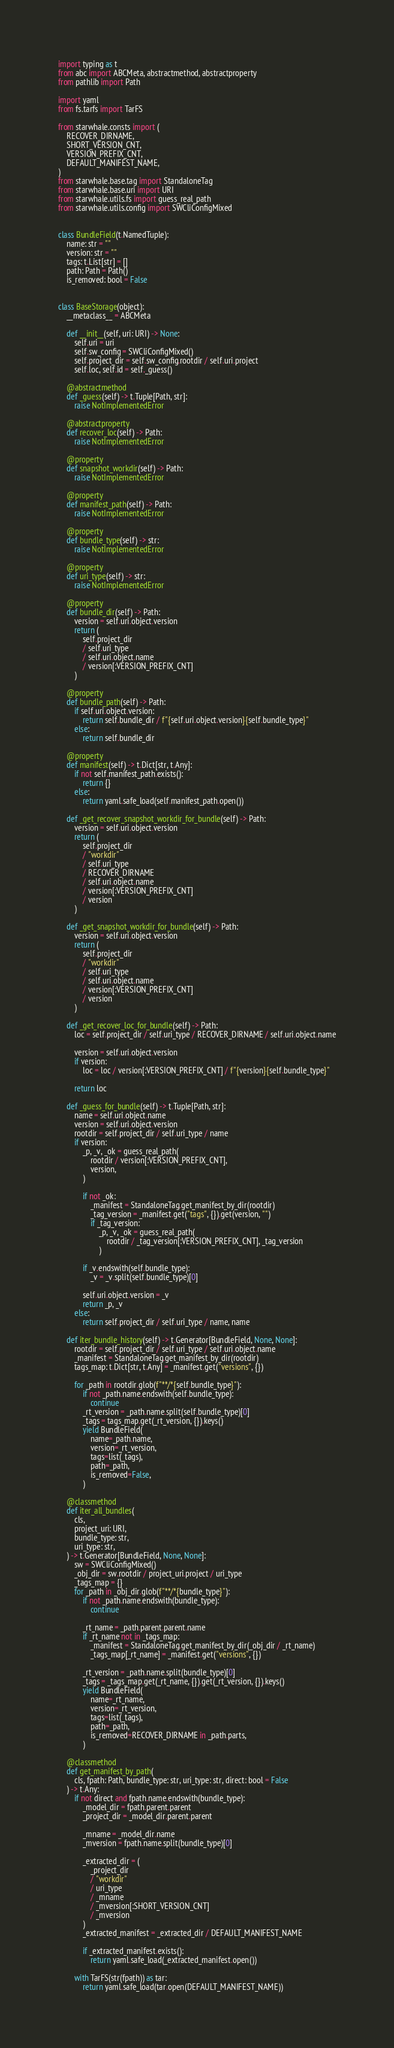<code> <loc_0><loc_0><loc_500><loc_500><_Python_>import typing as t
from abc import ABCMeta, abstractmethod, abstractproperty
from pathlib import Path

import yaml
from fs.tarfs import TarFS

from starwhale.consts import (
    RECOVER_DIRNAME,
    SHORT_VERSION_CNT,
    VERSION_PREFIX_CNT,
    DEFAULT_MANIFEST_NAME,
)
from starwhale.base.tag import StandaloneTag
from starwhale.base.uri import URI
from starwhale.utils.fs import guess_real_path
from starwhale.utils.config import SWCliConfigMixed


class BundleField(t.NamedTuple):
    name: str = ""
    version: str = ""
    tags: t.List[str] = []
    path: Path = Path()
    is_removed: bool = False


class BaseStorage(object):
    __metaclass__ = ABCMeta

    def __init__(self, uri: URI) -> None:
        self.uri = uri
        self.sw_config = SWCliConfigMixed()
        self.project_dir = self.sw_config.rootdir / self.uri.project
        self.loc, self.id = self._guess()

    @abstractmethod
    def _guess(self) -> t.Tuple[Path, str]:
        raise NotImplementedError

    @abstractproperty
    def recover_loc(self) -> Path:
        raise NotImplementedError

    @property
    def snapshot_workdir(self) -> Path:
        raise NotImplementedError

    @property
    def manifest_path(self) -> Path:
        raise NotImplementedError

    @property
    def bundle_type(self) -> str:
        raise NotImplementedError

    @property
    def uri_type(self) -> str:
        raise NotImplementedError

    @property
    def bundle_dir(self) -> Path:
        version = self.uri.object.version
        return (
            self.project_dir
            / self.uri_type
            / self.uri.object.name
            / version[:VERSION_PREFIX_CNT]
        )

    @property
    def bundle_path(self) -> Path:
        if self.uri.object.version:
            return self.bundle_dir / f"{self.uri.object.version}{self.bundle_type}"
        else:
            return self.bundle_dir

    @property
    def manifest(self) -> t.Dict[str, t.Any]:
        if not self.manifest_path.exists():
            return {}
        else:
            return yaml.safe_load(self.manifest_path.open())

    def _get_recover_snapshot_workdir_for_bundle(self) -> Path:
        version = self.uri.object.version
        return (
            self.project_dir
            / "workdir"
            / self.uri_type
            / RECOVER_DIRNAME
            / self.uri.object.name
            / version[:VERSION_PREFIX_CNT]
            / version
        )

    def _get_snapshot_workdir_for_bundle(self) -> Path:
        version = self.uri.object.version
        return (
            self.project_dir
            / "workdir"
            / self.uri_type
            / self.uri.object.name
            / version[:VERSION_PREFIX_CNT]
            / version
        )

    def _get_recover_loc_for_bundle(self) -> Path:
        loc = self.project_dir / self.uri_type / RECOVER_DIRNAME / self.uri.object.name

        version = self.uri.object.version
        if version:
            loc = loc / version[:VERSION_PREFIX_CNT] / f"{version}{self.bundle_type}"

        return loc

    def _guess_for_bundle(self) -> t.Tuple[Path, str]:
        name = self.uri.object.name
        version = self.uri.object.version
        rootdir = self.project_dir / self.uri_type / name
        if version:
            _p, _v, _ok = guess_real_path(
                rootdir / version[:VERSION_PREFIX_CNT],
                version,
            )

            if not _ok:
                _manifest = StandaloneTag.get_manifest_by_dir(rootdir)
                _tag_version = _manifest.get("tags", {}).get(version, "")
                if _tag_version:
                    _p, _v, _ok = guess_real_path(
                        rootdir / _tag_version[:VERSION_PREFIX_CNT], _tag_version
                    )

            if _v.endswith(self.bundle_type):
                _v = _v.split(self.bundle_type)[0]

            self.uri.object.version = _v
            return _p, _v
        else:
            return self.project_dir / self.uri_type / name, name

    def iter_bundle_history(self) -> t.Generator[BundleField, None, None]:
        rootdir = self.project_dir / self.uri_type / self.uri.object.name
        _manifest = StandaloneTag.get_manifest_by_dir(rootdir)
        tags_map: t.Dict[str, t.Any] = _manifest.get("versions", {})

        for _path in rootdir.glob(f"**/*{self.bundle_type}"):
            if not _path.name.endswith(self.bundle_type):
                continue
            _rt_version = _path.name.split(self.bundle_type)[0]
            _tags = tags_map.get(_rt_version, {}).keys()
            yield BundleField(
                name=_path.name,
                version=_rt_version,
                tags=list(_tags),
                path=_path,
                is_removed=False,
            )

    @classmethod
    def iter_all_bundles(
        cls,
        project_uri: URI,
        bundle_type: str,
        uri_type: str,
    ) -> t.Generator[BundleField, None, None]:
        sw = SWCliConfigMixed()
        _obj_dir = sw.rootdir / project_uri.project / uri_type
        _tags_map = {}
        for _path in _obj_dir.glob(f"**/*{bundle_type}"):
            if not _path.name.endswith(bundle_type):
                continue

            _rt_name = _path.parent.parent.name
            if _rt_name not in _tags_map:
                _manifest = StandaloneTag.get_manifest_by_dir(_obj_dir / _rt_name)
                _tags_map[_rt_name] = _manifest.get("versions", {})

            _rt_version = _path.name.split(bundle_type)[0]
            _tags = _tags_map.get(_rt_name, {}).get(_rt_version, {}).keys()
            yield BundleField(
                name=_rt_name,
                version=_rt_version,
                tags=list(_tags),
                path=_path,
                is_removed=RECOVER_DIRNAME in _path.parts,
            )

    @classmethod
    def get_manifest_by_path(
        cls, fpath: Path, bundle_type: str, uri_type: str, direct: bool = False
    ) -> t.Any:
        if not direct and fpath.name.endswith(bundle_type):
            _model_dir = fpath.parent.parent
            _project_dir = _model_dir.parent.parent

            _mname = _model_dir.name
            _mversion = fpath.name.split(bundle_type)[0]

            _extracted_dir = (
                _project_dir
                / "workdir"
                / uri_type
                / _mname
                / _mversion[:SHORT_VERSION_CNT]
                / _mversion
            )
            _extracted_manifest = _extracted_dir / DEFAULT_MANIFEST_NAME

            if _extracted_manifest.exists():
                return yaml.safe_load(_extracted_manifest.open())

        with TarFS(str(fpath)) as tar:
            return yaml.safe_load(tar.open(DEFAULT_MANIFEST_NAME))
</code> 